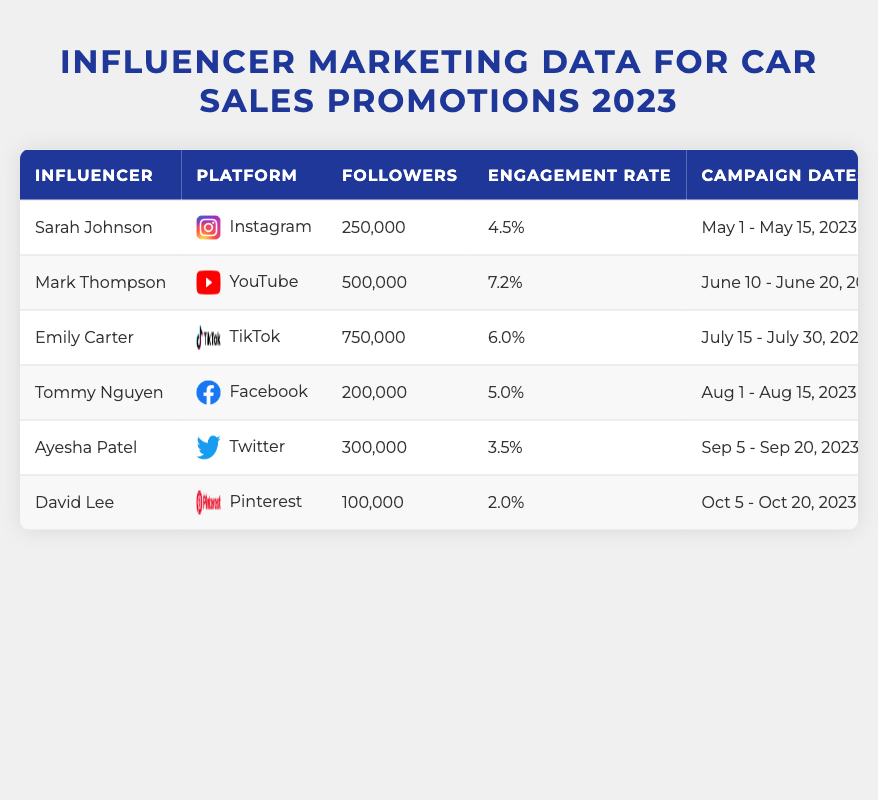What is the engagement rate of Mark Thompson? By looking at the row for Mark Thompson, the Engagement Rate column shows a value of 7.2%.
Answer: 7.2% Which influencer generated the highest number of leads? Emily Carter generated 250 leads, which is the highest number among all influencers listed in the table.
Answer: Emily Carter What is the cost of the campaign for Ayesha Patel? The Cost of Campaign column for Ayesha Patel states the amount is $3,000.
Answer: $3,000 Which car brand had the highest sales increase percentage? Mark Thompson's campaign for Tesla shows a sales increase percentage of 35%, the highest in the table.
Answer: Tesla If we consider the total campaign cost for all influencers, what is that amount? The total campaign cost is calculated by summing all individual campaign costs: $5,000 + $10,000 + $7,000 + $4,000 + $3,000 + $2,000 = $31,000.
Answer: $31,000 Did any influencer promote a car model with a sales increase percentage below 15%? Yes, David Lee promoted the Nissan Altima with a sales increase percentage of 10%.
Answer: Yes What is the average engagement rate of all the influencers? To find the average engagement rate, add all engagement rates (4.5 + 7.2 + 6.0 + 5.0 + 3.5 + 2.0) = 28.2, then divide by the number of influencers (6): 28.2 / 6 = 4.7%.
Answer: 4.7% Which influencer had the shortest campaign duration, and what were the dates? The campaign for Sarah Johnson lasted from May 1 to May 15, totaling 15 days, which is the shortest duration among all campaigns.
Answer: Sarah Johnson, May 1 - May 15 Is there a correlation between the number of followers and the sales increase percentage? Looking at the data, Mark Thompson with 500,000 followers and a 35% sales increase indicates a trend where higher followers might lead to higher sales increases, but not all influencers show this. Thus, while there may be some correlation, it is not definitive.
Answer: Not definitive What is the total sales increase percentage across all campaigns? The total sales increase percentage is calculated by adding all sales increases: 20 + 35 + 25 + 18 + 15 + 10 = 113%.
Answer: 113% 